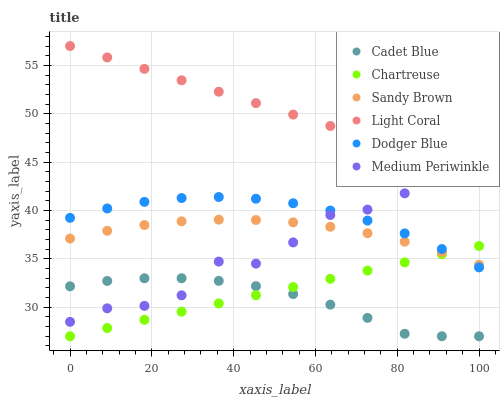Does Cadet Blue have the minimum area under the curve?
Answer yes or no. Yes. Does Light Coral have the maximum area under the curve?
Answer yes or no. Yes. Does Medium Periwinkle have the minimum area under the curve?
Answer yes or no. No. Does Medium Periwinkle have the maximum area under the curve?
Answer yes or no. No. Is Light Coral the smoothest?
Answer yes or no. Yes. Is Medium Periwinkle the roughest?
Answer yes or no. Yes. Is Medium Periwinkle the smoothest?
Answer yes or no. No. Is Light Coral the roughest?
Answer yes or no. No. Does Cadet Blue have the lowest value?
Answer yes or no. Yes. Does Medium Periwinkle have the lowest value?
Answer yes or no. No. Does Light Coral have the highest value?
Answer yes or no. Yes. Does Medium Periwinkle have the highest value?
Answer yes or no. No. Is Chartreuse less than Medium Periwinkle?
Answer yes or no. Yes. Is Light Coral greater than Cadet Blue?
Answer yes or no. Yes. Does Cadet Blue intersect Chartreuse?
Answer yes or no. Yes. Is Cadet Blue less than Chartreuse?
Answer yes or no. No. Is Cadet Blue greater than Chartreuse?
Answer yes or no. No. Does Chartreuse intersect Medium Periwinkle?
Answer yes or no. No. 